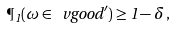Convert formula to latex. <formula><loc_0><loc_0><loc_500><loc_500>\P _ { 1 } ( \omega \in \ v g o o d ^ { \prime } ) \geq 1 - \delta \, ,</formula> 